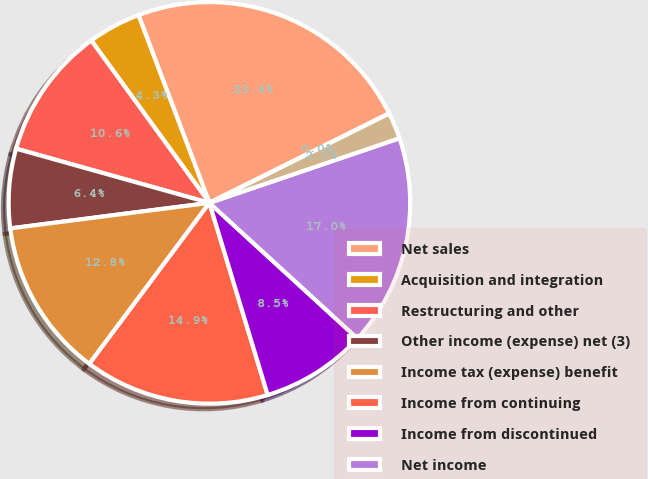Convert chart to OTSL. <chart><loc_0><loc_0><loc_500><loc_500><pie_chart><fcel>Net sales<fcel>Acquisition and integration<fcel>Restructuring and other<fcel>Other income (expense) net (3)<fcel>Income tax (expense) benefit<fcel>Income from continuing<fcel>Income from discontinued<fcel>Net income<fcel>Connectivity Ltd Income from<fcel>Dividends and cash<nl><fcel>23.4%<fcel>4.26%<fcel>10.64%<fcel>6.38%<fcel>12.77%<fcel>14.89%<fcel>8.51%<fcel>17.02%<fcel>2.13%<fcel>0.0%<nl></chart> 